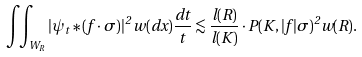<formula> <loc_0><loc_0><loc_500><loc_500>\iint _ { W _ { R } } | \psi _ { t } \ast ( f \cdot \sigma ) | ^ { 2 } \, w ( d x ) \frac { d t } t \lesssim \frac { l ( R ) } { l ( K ) } \cdot P ( K , | f | \sigma ) ^ { 2 } w ( R ) .</formula> 